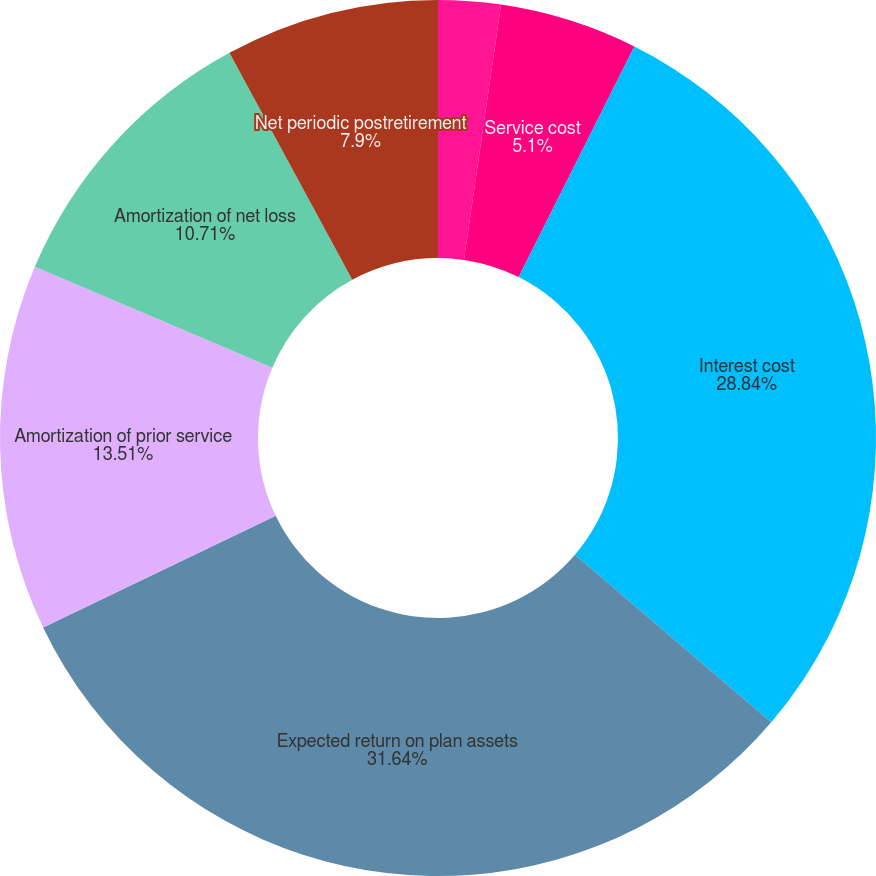Convert chart. <chart><loc_0><loc_0><loc_500><loc_500><pie_chart><fcel>(Thousands of Dollars)<fcel>Service cost<fcel>Interest cost<fcel>Expected return on plan assets<fcel>Amortization of prior service<fcel>Amortization of net loss<fcel>Net periodic postretirement<nl><fcel>2.3%<fcel>5.1%<fcel>28.84%<fcel>31.64%<fcel>13.51%<fcel>10.71%<fcel>7.9%<nl></chart> 